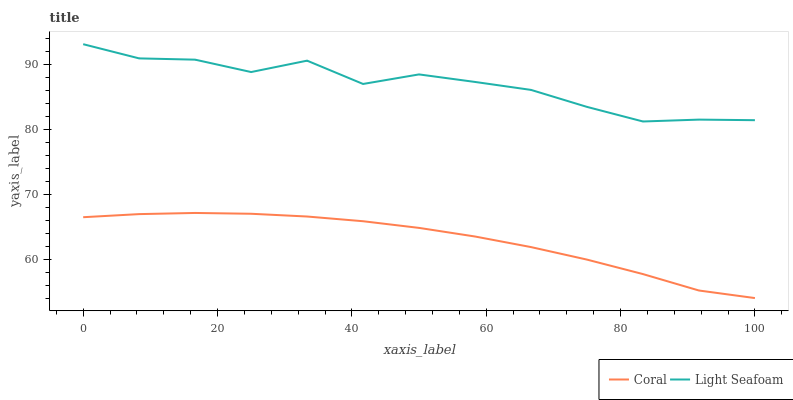Does Coral have the minimum area under the curve?
Answer yes or no. Yes. Does Light Seafoam have the maximum area under the curve?
Answer yes or no. Yes. Does Light Seafoam have the minimum area under the curve?
Answer yes or no. No. Is Coral the smoothest?
Answer yes or no. Yes. Is Light Seafoam the roughest?
Answer yes or no. Yes. Is Light Seafoam the smoothest?
Answer yes or no. No. Does Coral have the lowest value?
Answer yes or no. Yes. Does Light Seafoam have the lowest value?
Answer yes or no. No. Does Light Seafoam have the highest value?
Answer yes or no. Yes. Is Coral less than Light Seafoam?
Answer yes or no. Yes. Is Light Seafoam greater than Coral?
Answer yes or no. Yes. Does Coral intersect Light Seafoam?
Answer yes or no. No. 